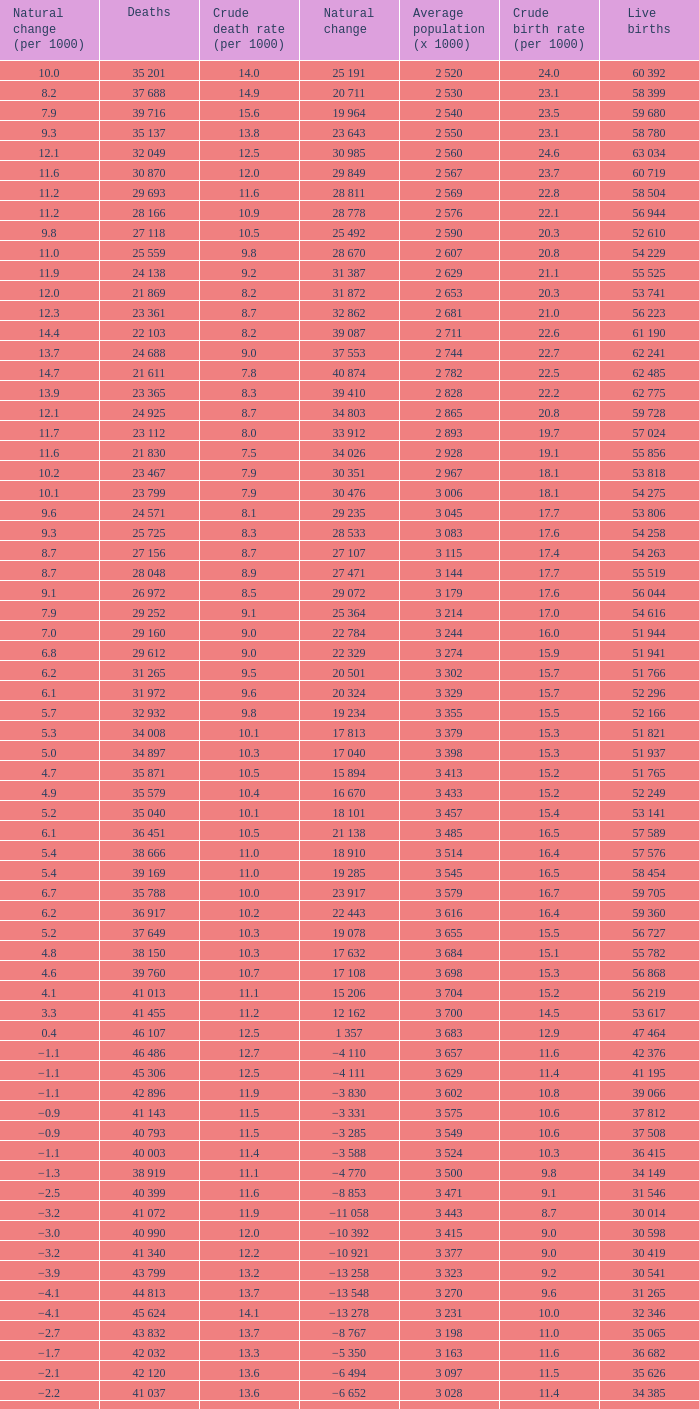Give me the full table as a dictionary. {'header': ['Natural change (per 1000)', 'Deaths', 'Crude death rate (per 1000)', 'Natural change', 'Average population (x 1000)', 'Crude birth rate (per 1000)', 'Live births'], 'rows': [['10.0', '35 201', '14.0', '25 191', '2 520', '24.0', '60 392'], ['8.2', '37 688', '14.9', '20 711', '2 530', '23.1', '58 399'], ['7.9', '39 716', '15.6', '19 964', '2 540', '23.5', '59 680'], ['9.3', '35 137', '13.8', '23 643', '2 550', '23.1', '58 780'], ['12.1', '32 049', '12.5', '30 985', '2 560', '24.6', '63 034'], ['11.6', '30 870', '12.0', '29 849', '2 567', '23.7', '60 719'], ['11.2', '29 693', '11.6', '28 811', '2 569', '22.8', '58 504'], ['11.2', '28 166', '10.9', '28 778', '2 576', '22.1', '56 944'], ['9.8', '27 118', '10.5', '25 492', '2 590', '20.3', '52 610'], ['11.0', '25 559', '9.8', '28 670', '2 607', '20.8', '54 229'], ['11.9', '24 138', '9.2', '31 387', '2 629', '21.1', '55 525'], ['12.0', '21 869', '8.2', '31 872', '2 653', '20.3', '53 741'], ['12.3', '23 361', '8.7', '32 862', '2 681', '21.0', '56 223'], ['14.4', '22 103', '8.2', '39 087', '2 711', '22.6', '61 190'], ['13.7', '24 688', '9.0', '37 553', '2 744', '22.7', '62 241'], ['14.7', '21 611', '7.8', '40 874', '2 782', '22.5', '62 485'], ['13.9', '23 365', '8.3', '39 410', '2 828', '22.2', '62 775'], ['12.1', '24 925', '8.7', '34 803', '2 865', '20.8', '59 728'], ['11.7', '23 112', '8.0', '33 912', '2 893', '19.7', '57 024'], ['11.6', '21 830', '7.5', '34 026', '2 928', '19.1', '55 856'], ['10.2', '23 467', '7.9', '30 351', '2 967', '18.1', '53 818'], ['10.1', '23 799', '7.9', '30 476', '3 006', '18.1', '54 275'], ['9.6', '24 571', '8.1', '29 235', '3 045', '17.7', '53 806'], ['9.3', '25 725', '8.3', '28 533', '3 083', '17.6', '54 258'], ['8.7', '27 156', '8.7', '27 107', '3 115', '17.4', '54 263'], ['8.7', '28 048', '8.9', '27 471', '3 144', '17.7', '55 519'], ['9.1', '26 972', '8.5', '29 072', '3 179', '17.6', '56 044'], ['7.9', '29 252', '9.1', '25 364', '3 214', '17.0', '54 616'], ['7.0', '29 160', '9.0', '22 784', '3 244', '16.0', '51 944'], ['6.8', '29 612', '9.0', '22 329', '3 274', '15.9', '51 941'], ['6.2', '31 265', '9.5', '20 501', '3 302', '15.7', '51 766'], ['6.1', '31 972', '9.6', '20 324', '3 329', '15.7', '52 296'], ['5.7', '32 932', '9.8', '19 234', '3 355', '15.5', '52 166'], ['5.3', '34 008', '10.1', '17 813', '3 379', '15.3', '51 821'], ['5.0', '34 897', '10.3', '17 040', '3 398', '15.3', '51 937'], ['4.7', '35 871', '10.5', '15 894', '3 413', '15.2', '51 765'], ['4.9', '35 579', '10.4', '16 670', '3 433', '15.2', '52 249'], ['5.2', '35 040', '10.1', '18 101', '3 457', '15.4', '53 141'], ['6.1', '36 451', '10.5', '21 138', '3 485', '16.5', '57 589'], ['5.4', '38 666', '11.0', '18 910', '3 514', '16.4', '57 576'], ['5.4', '39 169', '11.0', '19 285', '3 545', '16.5', '58 454'], ['6.7', '35 788', '10.0', '23 917', '3 579', '16.7', '59 705'], ['6.2', '36 917', '10.2', '22 443', '3 616', '16.4', '59 360'], ['5.2', '37 649', '10.3', '19 078', '3 655', '15.5', '56 727'], ['4.8', '38 150', '10.3', '17 632', '3 684', '15.1', '55 782'], ['4.6', '39 760', '10.7', '17 108', '3 698', '15.3', '56 868'], ['4.1', '41 013', '11.1', '15 206', '3 704', '15.2', '56 219'], ['3.3', '41 455', '11.2', '12 162', '3 700', '14.5', '53 617'], ['0.4', '46 107', '12.5', '1 357', '3 683', '12.9', '47 464'], ['−1.1', '46 486', '12.7', '−4 110', '3 657', '11.6', '42 376'], ['−1.1', '45 306', '12.5', '−4 111', '3 629', '11.4', '41 195'], ['−1.1', '42 896', '11.9', '−3 830', '3 602', '10.8', '39 066'], ['−0.9', '41 143', '11.5', '−3 331', '3 575', '10.6', '37 812'], ['−0.9', '40 793', '11.5', '−3 285', '3 549', '10.6', '37 508'], ['−1.1', '40 003', '11.4', '−3 588', '3 524', '10.3', '36 415'], ['−1.3', '38 919', '11.1', '−4 770', '3 500', '9.8', '34 149'], ['−2.5', '40 399', '11.6', '−8 853', '3 471', '9.1', '31 546'], ['−3.2', '41 072', '11.9', '−11 058', '3 443', '8.7', '30 014'], ['−3.0', '40 990', '12.0', '−10 392', '3 415', '9.0', '30 598'], ['−3.2', '41 340', '12.2', '−10 921', '3 377', '9.0', '30 419'], ['−3.9', '43 799', '13.2', '−13 258', '3 323', '9.2', '30 541'], ['−4.1', '44 813', '13.7', '−13 548', '3 270', '9.6', '31 265'], ['−4.1', '45 624', '14.1', '−13 278', '3 231', '10.0', '32 346'], ['−2.7', '43 832', '13.7', '−8 767', '3 198', '11.0', '35 065'], ['−1.7', '42 032', '13.3', '−5 350', '3 163', '11.6', '36 682'], ['−2.1', '42 120', '13.6', '−6 494', '3 097', '11.5', '35 626'], ['−2.2', '41 037', '13.6', '−6 652', '3 028', '11.4', '34 385'], ['−3.5', '40 938', '13.7', '−10 479', '2 988', '10.2', '30 459']]} Which Natural change has a Crude death rate (per 1000) larger than 9, and Deaths of 40 399? −8 853. 